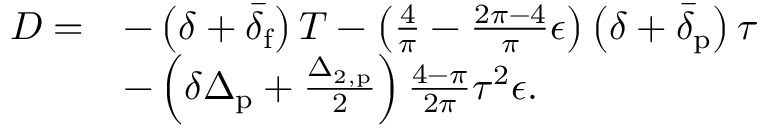Convert formula to latex. <formula><loc_0><loc_0><loc_500><loc_500>\begin{array} { r l } { D = } & { - \left ( \delta + \bar { \delta } _ { f } \right ) T - \left ( \frac { 4 } { \pi } - \frac { 2 \pi - 4 } { \pi } \epsilon \right ) \left ( \delta + \bar { \delta } _ { p } \right ) \tau } \\ & { - \left ( \delta \Delta _ { p } + \frac { \Delta _ { 2 , p } } { 2 } \right ) \frac { 4 - \pi } { 2 \pi } \tau ^ { 2 } \epsilon . } \end{array}</formula> 